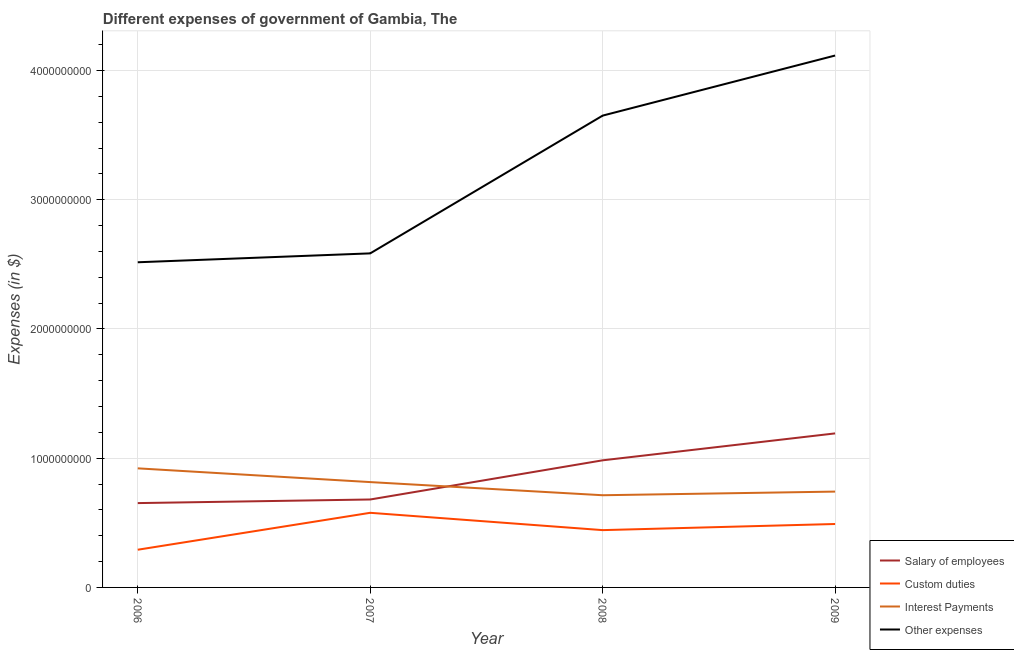What is the amount spent on other expenses in 2008?
Make the answer very short. 3.65e+09. Across all years, what is the maximum amount spent on interest payments?
Offer a very short reply. 9.21e+08. Across all years, what is the minimum amount spent on custom duties?
Your response must be concise. 2.92e+08. In which year was the amount spent on custom duties maximum?
Provide a short and direct response. 2007. In which year was the amount spent on other expenses minimum?
Give a very brief answer. 2006. What is the total amount spent on custom duties in the graph?
Offer a terse response. 1.80e+09. What is the difference between the amount spent on salary of employees in 2007 and that in 2008?
Your answer should be very brief. -3.03e+08. What is the difference between the amount spent on salary of employees in 2009 and the amount spent on other expenses in 2007?
Offer a terse response. -1.39e+09. What is the average amount spent on other expenses per year?
Provide a succinct answer. 3.22e+09. In the year 2006, what is the difference between the amount spent on salary of employees and amount spent on other expenses?
Offer a terse response. -1.86e+09. In how many years, is the amount spent on custom duties greater than 1200000000 $?
Offer a terse response. 0. What is the ratio of the amount spent on other expenses in 2007 to that in 2008?
Provide a succinct answer. 0.71. Is the difference between the amount spent on interest payments in 2006 and 2009 greater than the difference between the amount spent on other expenses in 2006 and 2009?
Offer a terse response. Yes. What is the difference between the highest and the second highest amount spent on other expenses?
Offer a terse response. 4.65e+08. What is the difference between the highest and the lowest amount spent on other expenses?
Offer a terse response. 1.60e+09. In how many years, is the amount spent on other expenses greater than the average amount spent on other expenses taken over all years?
Provide a short and direct response. 2. Is the sum of the amount spent on interest payments in 2007 and 2009 greater than the maximum amount spent on custom duties across all years?
Your response must be concise. Yes. Is it the case that in every year, the sum of the amount spent on salary of employees and amount spent on custom duties is greater than the amount spent on interest payments?
Make the answer very short. Yes. Does the amount spent on other expenses monotonically increase over the years?
Your answer should be compact. Yes. How many years are there in the graph?
Your response must be concise. 4. What is the difference between two consecutive major ticks on the Y-axis?
Ensure brevity in your answer.  1.00e+09. Are the values on the major ticks of Y-axis written in scientific E-notation?
Provide a succinct answer. No. Does the graph contain grids?
Provide a succinct answer. Yes. How many legend labels are there?
Provide a succinct answer. 4. What is the title of the graph?
Your response must be concise. Different expenses of government of Gambia, The. What is the label or title of the X-axis?
Ensure brevity in your answer.  Year. What is the label or title of the Y-axis?
Keep it short and to the point. Expenses (in $). What is the Expenses (in $) of Salary of employees in 2006?
Give a very brief answer. 6.52e+08. What is the Expenses (in $) in Custom duties in 2006?
Provide a succinct answer. 2.92e+08. What is the Expenses (in $) of Interest Payments in 2006?
Provide a succinct answer. 9.21e+08. What is the Expenses (in $) in Other expenses in 2006?
Your answer should be compact. 2.52e+09. What is the Expenses (in $) of Salary of employees in 2007?
Give a very brief answer. 6.80e+08. What is the Expenses (in $) of Custom duties in 2007?
Provide a short and direct response. 5.77e+08. What is the Expenses (in $) in Interest Payments in 2007?
Make the answer very short. 8.15e+08. What is the Expenses (in $) in Other expenses in 2007?
Provide a succinct answer. 2.58e+09. What is the Expenses (in $) of Salary of employees in 2008?
Your answer should be very brief. 9.84e+08. What is the Expenses (in $) in Custom duties in 2008?
Your answer should be compact. 4.43e+08. What is the Expenses (in $) in Interest Payments in 2008?
Give a very brief answer. 7.13e+08. What is the Expenses (in $) in Other expenses in 2008?
Your response must be concise. 3.65e+09. What is the Expenses (in $) of Salary of employees in 2009?
Give a very brief answer. 1.19e+09. What is the Expenses (in $) of Custom duties in 2009?
Make the answer very short. 4.91e+08. What is the Expenses (in $) of Interest Payments in 2009?
Provide a succinct answer. 7.42e+08. What is the Expenses (in $) in Other expenses in 2009?
Make the answer very short. 4.12e+09. Across all years, what is the maximum Expenses (in $) of Salary of employees?
Ensure brevity in your answer.  1.19e+09. Across all years, what is the maximum Expenses (in $) in Custom duties?
Provide a short and direct response. 5.77e+08. Across all years, what is the maximum Expenses (in $) of Interest Payments?
Give a very brief answer. 9.21e+08. Across all years, what is the maximum Expenses (in $) in Other expenses?
Keep it short and to the point. 4.12e+09. Across all years, what is the minimum Expenses (in $) in Salary of employees?
Your answer should be compact. 6.52e+08. Across all years, what is the minimum Expenses (in $) of Custom duties?
Ensure brevity in your answer.  2.92e+08. Across all years, what is the minimum Expenses (in $) of Interest Payments?
Your response must be concise. 7.13e+08. Across all years, what is the minimum Expenses (in $) in Other expenses?
Ensure brevity in your answer.  2.52e+09. What is the total Expenses (in $) of Salary of employees in the graph?
Your response must be concise. 3.51e+09. What is the total Expenses (in $) of Custom duties in the graph?
Provide a short and direct response. 1.80e+09. What is the total Expenses (in $) of Interest Payments in the graph?
Provide a short and direct response. 3.19e+09. What is the total Expenses (in $) of Other expenses in the graph?
Offer a terse response. 1.29e+1. What is the difference between the Expenses (in $) of Salary of employees in 2006 and that in 2007?
Keep it short and to the point. -2.79e+07. What is the difference between the Expenses (in $) of Custom duties in 2006 and that in 2007?
Your answer should be very brief. -2.86e+08. What is the difference between the Expenses (in $) of Interest Payments in 2006 and that in 2007?
Offer a very short reply. 1.06e+08. What is the difference between the Expenses (in $) of Other expenses in 2006 and that in 2007?
Keep it short and to the point. -6.88e+07. What is the difference between the Expenses (in $) in Salary of employees in 2006 and that in 2008?
Your answer should be compact. -3.31e+08. What is the difference between the Expenses (in $) of Custom duties in 2006 and that in 2008?
Provide a succinct answer. -1.52e+08. What is the difference between the Expenses (in $) in Interest Payments in 2006 and that in 2008?
Provide a short and direct response. 2.08e+08. What is the difference between the Expenses (in $) in Other expenses in 2006 and that in 2008?
Make the answer very short. -1.13e+09. What is the difference between the Expenses (in $) in Salary of employees in 2006 and that in 2009?
Ensure brevity in your answer.  -5.39e+08. What is the difference between the Expenses (in $) of Custom duties in 2006 and that in 2009?
Make the answer very short. -1.99e+08. What is the difference between the Expenses (in $) in Interest Payments in 2006 and that in 2009?
Offer a terse response. 1.80e+08. What is the difference between the Expenses (in $) in Other expenses in 2006 and that in 2009?
Offer a terse response. -1.60e+09. What is the difference between the Expenses (in $) of Salary of employees in 2007 and that in 2008?
Offer a terse response. -3.03e+08. What is the difference between the Expenses (in $) in Custom duties in 2007 and that in 2008?
Your response must be concise. 1.34e+08. What is the difference between the Expenses (in $) of Interest Payments in 2007 and that in 2008?
Your answer should be very brief. 1.02e+08. What is the difference between the Expenses (in $) in Other expenses in 2007 and that in 2008?
Your answer should be compact. -1.07e+09. What is the difference between the Expenses (in $) in Salary of employees in 2007 and that in 2009?
Ensure brevity in your answer.  -5.11e+08. What is the difference between the Expenses (in $) in Custom duties in 2007 and that in 2009?
Your answer should be compact. 8.66e+07. What is the difference between the Expenses (in $) of Interest Payments in 2007 and that in 2009?
Provide a short and direct response. 7.35e+07. What is the difference between the Expenses (in $) of Other expenses in 2007 and that in 2009?
Give a very brief answer. -1.53e+09. What is the difference between the Expenses (in $) of Salary of employees in 2008 and that in 2009?
Make the answer very short. -2.08e+08. What is the difference between the Expenses (in $) in Custom duties in 2008 and that in 2009?
Provide a succinct answer. -4.74e+07. What is the difference between the Expenses (in $) in Interest Payments in 2008 and that in 2009?
Offer a terse response. -2.82e+07. What is the difference between the Expenses (in $) of Other expenses in 2008 and that in 2009?
Ensure brevity in your answer.  -4.65e+08. What is the difference between the Expenses (in $) of Salary of employees in 2006 and the Expenses (in $) of Custom duties in 2007?
Ensure brevity in your answer.  7.51e+07. What is the difference between the Expenses (in $) of Salary of employees in 2006 and the Expenses (in $) of Interest Payments in 2007?
Provide a short and direct response. -1.62e+08. What is the difference between the Expenses (in $) of Salary of employees in 2006 and the Expenses (in $) of Other expenses in 2007?
Ensure brevity in your answer.  -1.93e+09. What is the difference between the Expenses (in $) of Custom duties in 2006 and the Expenses (in $) of Interest Payments in 2007?
Ensure brevity in your answer.  -5.23e+08. What is the difference between the Expenses (in $) in Custom duties in 2006 and the Expenses (in $) in Other expenses in 2007?
Provide a succinct answer. -2.29e+09. What is the difference between the Expenses (in $) in Interest Payments in 2006 and the Expenses (in $) in Other expenses in 2007?
Offer a very short reply. -1.66e+09. What is the difference between the Expenses (in $) in Salary of employees in 2006 and the Expenses (in $) in Custom duties in 2008?
Provide a succinct answer. 2.09e+08. What is the difference between the Expenses (in $) of Salary of employees in 2006 and the Expenses (in $) of Interest Payments in 2008?
Provide a succinct answer. -6.08e+07. What is the difference between the Expenses (in $) of Salary of employees in 2006 and the Expenses (in $) of Other expenses in 2008?
Your answer should be very brief. -3.00e+09. What is the difference between the Expenses (in $) of Custom duties in 2006 and the Expenses (in $) of Interest Payments in 2008?
Your response must be concise. -4.22e+08. What is the difference between the Expenses (in $) of Custom duties in 2006 and the Expenses (in $) of Other expenses in 2008?
Your answer should be very brief. -3.36e+09. What is the difference between the Expenses (in $) of Interest Payments in 2006 and the Expenses (in $) of Other expenses in 2008?
Ensure brevity in your answer.  -2.73e+09. What is the difference between the Expenses (in $) of Salary of employees in 2006 and the Expenses (in $) of Custom duties in 2009?
Provide a short and direct response. 1.62e+08. What is the difference between the Expenses (in $) of Salary of employees in 2006 and the Expenses (in $) of Interest Payments in 2009?
Provide a succinct answer. -8.90e+07. What is the difference between the Expenses (in $) of Salary of employees in 2006 and the Expenses (in $) of Other expenses in 2009?
Give a very brief answer. -3.46e+09. What is the difference between the Expenses (in $) in Custom duties in 2006 and the Expenses (in $) in Interest Payments in 2009?
Provide a short and direct response. -4.50e+08. What is the difference between the Expenses (in $) in Custom duties in 2006 and the Expenses (in $) in Other expenses in 2009?
Your answer should be compact. -3.82e+09. What is the difference between the Expenses (in $) in Interest Payments in 2006 and the Expenses (in $) in Other expenses in 2009?
Provide a short and direct response. -3.19e+09. What is the difference between the Expenses (in $) of Salary of employees in 2007 and the Expenses (in $) of Custom duties in 2008?
Ensure brevity in your answer.  2.37e+08. What is the difference between the Expenses (in $) in Salary of employees in 2007 and the Expenses (in $) in Interest Payments in 2008?
Give a very brief answer. -3.29e+07. What is the difference between the Expenses (in $) in Salary of employees in 2007 and the Expenses (in $) in Other expenses in 2008?
Your answer should be very brief. -2.97e+09. What is the difference between the Expenses (in $) of Custom duties in 2007 and the Expenses (in $) of Interest Payments in 2008?
Offer a terse response. -1.36e+08. What is the difference between the Expenses (in $) in Custom duties in 2007 and the Expenses (in $) in Other expenses in 2008?
Provide a succinct answer. -3.07e+09. What is the difference between the Expenses (in $) of Interest Payments in 2007 and the Expenses (in $) of Other expenses in 2008?
Offer a very short reply. -2.84e+09. What is the difference between the Expenses (in $) of Salary of employees in 2007 and the Expenses (in $) of Custom duties in 2009?
Provide a short and direct response. 1.90e+08. What is the difference between the Expenses (in $) of Salary of employees in 2007 and the Expenses (in $) of Interest Payments in 2009?
Offer a terse response. -6.11e+07. What is the difference between the Expenses (in $) in Salary of employees in 2007 and the Expenses (in $) in Other expenses in 2009?
Make the answer very short. -3.44e+09. What is the difference between the Expenses (in $) of Custom duties in 2007 and the Expenses (in $) of Interest Payments in 2009?
Your answer should be compact. -1.64e+08. What is the difference between the Expenses (in $) of Custom duties in 2007 and the Expenses (in $) of Other expenses in 2009?
Provide a short and direct response. -3.54e+09. What is the difference between the Expenses (in $) in Interest Payments in 2007 and the Expenses (in $) in Other expenses in 2009?
Your answer should be compact. -3.30e+09. What is the difference between the Expenses (in $) in Salary of employees in 2008 and the Expenses (in $) in Custom duties in 2009?
Offer a terse response. 4.93e+08. What is the difference between the Expenses (in $) in Salary of employees in 2008 and the Expenses (in $) in Interest Payments in 2009?
Provide a succinct answer. 2.42e+08. What is the difference between the Expenses (in $) of Salary of employees in 2008 and the Expenses (in $) of Other expenses in 2009?
Make the answer very short. -3.13e+09. What is the difference between the Expenses (in $) of Custom duties in 2008 and the Expenses (in $) of Interest Payments in 2009?
Make the answer very short. -2.98e+08. What is the difference between the Expenses (in $) in Custom duties in 2008 and the Expenses (in $) in Other expenses in 2009?
Provide a succinct answer. -3.67e+09. What is the difference between the Expenses (in $) in Interest Payments in 2008 and the Expenses (in $) in Other expenses in 2009?
Offer a terse response. -3.40e+09. What is the average Expenses (in $) in Salary of employees per year?
Provide a succinct answer. 8.77e+08. What is the average Expenses (in $) in Custom duties per year?
Your response must be concise. 4.51e+08. What is the average Expenses (in $) in Interest Payments per year?
Your answer should be compact. 7.98e+08. What is the average Expenses (in $) in Other expenses per year?
Your answer should be compact. 3.22e+09. In the year 2006, what is the difference between the Expenses (in $) of Salary of employees and Expenses (in $) of Custom duties?
Make the answer very short. 3.61e+08. In the year 2006, what is the difference between the Expenses (in $) in Salary of employees and Expenses (in $) in Interest Payments?
Your answer should be very brief. -2.69e+08. In the year 2006, what is the difference between the Expenses (in $) in Salary of employees and Expenses (in $) in Other expenses?
Ensure brevity in your answer.  -1.86e+09. In the year 2006, what is the difference between the Expenses (in $) in Custom duties and Expenses (in $) in Interest Payments?
Ensure brevity in your answer.  -6.30e+08. In the year 2006, what is the difference between the Expenses (in $) in Custom duties and Expenses (in $) in Other expenses?
Give a very brief answer. -2.22e+09. In the year 2006, what is the difference between the Expenses (in $) of Interest Payments and Expenses (in $) of Other expenses?
Provide a succinct answer. -1.59e+09. In the year 2007, what is the difference between the Expenses (in $) in Salary of employees and Expenses (in $) in Custom duties?
Your answer should be very brief. 1.03e+08. In the year 2007, what is the difference between the Expenses (in $) of Salary of employees and Expenses (in $) of Interest Payments?
Your response must be concise. -1.35e+08. In the year 2007, what is the difference between the Expenses (in $) of Salary of employees and Expenses (in $) of Other expenses?
Give a very brief answer. -1.90e+09. In the year 2007, what is the difference between the Expenses (in $) of Custom duties and Expenses (in $) of Interest Payments?
Your response must be concise. -2.38e+08. In the year 2007, what is the difference between the Expenses (in $) of Custom duties and Expenses (in $) of Other expenses?
Ensure brevity in your answer.  -2.01e+09. In the year 2007, what is the difference between the Expenses (in $) of Interest Payments and Expenses (in $) of Other expenses?
Ensure brevity in your answer.  -1.77e+09. In the year 2008, what is the difference between the Expenses (in $) in Salary of employees and Expenses (in $) in Custom duties?
Keep it short and to the point. 5.40e+08. In the year 2008, what is the difference between the Expenses (in $) of Salary of employees and Expenses (in $) of Interest Payments?
Keep it short and to the point. 2.70e+08. In the year 2008, what is the difference between the Expenses (in $) in Salary of employees and Expenses (in $) in Other expenses?
Offer a terse response. -2.67e+09. In the year 2008, what is the difference between the Expenses (in $) in Custom duties and Expenses (in $) in Interest Payments?
Provide a short and direct response. -2.70e+08. In the year 2008, what is the difference between the Expenses (in $) in Custom duties and Expenses (in $) in Other expenses?
Offer a very short reply. -3.21e+09. In the year 2008, what is the difference between the Expenses (in $) of Interest Payments and Expenses (in $) of Other expenses?
Offer a very short reply. -2.94e+09. In the year 2009, what is the difference between the Expenses (in $) of Salary of employees and Expenses (in $) of Custom duties?
Make the answer very short. 7.01e+08. In the year 2009, what is the difference between the Expenses (in $) of Salary of employees and Expenses (in $) of Interest Payments?
Offer a very short reply. 4.50e+08. In the year 2009, what is the difference between the Expenses (in $) of Salary of employees and Expenses (in $) of Other expenses?
Keep it short and to the point. -2.92e+09. In the year 2009, what is the difference between the Expenses (in $) of Custom duties and Expenses (in $) of Interest Payments?
Keep it short and to the point. -2.51e+08. In the year 2009, what is the difference between the Expenses (in $) of Custom duties and Expenses (in $) of Other expenses?
Provide a succinct answer. -3.62e+09. In the year 2009, what is the difference between the Expenses (in $) of Interest Payments and Expenses (in $) of Other expenses?
Provide a succinct answer. -3.37e+09. What is the ratio of the Expenses (in $) in Salary of employees in 2006 to that in 2007?
Offer a terse response. 0.96. What is the ratio of the Expenses (in $) of Custom duties in 2006 to that in 2007?
Your answer should be compact. 0.51. What is the ratio of the Expenses (in $) of Interest Payments in 2006 to that in 2007?
Offer a very short reply. 1.13. What is the ratio of the Expenses (in $) of Other expenses in 2006 to that in 2007?
Provide a short and direct response. 0.97. What is the ratio of the Expenses (in $) of Salary of employees in 2006 to that in 2008?
Provide a short and direct response. 0.66. What is the ratio of the Expenses (in $) in Custom duties in 2006 to that in 2008?
Make the answer very short. 0.66. What is the ratio of the Expenses (in $) in Interest Payments in 2006 to that in 2008?
Ensure brevity in your answer.  1.29. What is the ratio of the Expenses (in $) of Other expenses in 2006 to that in 2008?
Offer a very short reply. 0.69. What is the ratio of the Expenses (in $) in Salary of employees in 2006 to that in 2009?
Offer a terse response. 0.55. What is the ratio of the Expenses (in $) in Custom duties in 2006 to that in 2009?
Make the answer very short. 0.59. What is the ratio of the Expenses (in $) in Interest Payments in 2006 to that in 2009?
Make the answer very short. 1.24. What is the ratio of the Expenses (in $) in Other expenses in 2006 to that in 2009?
Your answer should be compact. 0.61. What is the ratio of the Expenses (in $) of Salary of employees in 2007 to that in 2008?
Give a very brief answer. 0.69. What is the ratio of the Expenses (in $) of Custom duties in 2007 to that in 2008?
Your response must be concise. 1.3. What is the ratio of the Expenses (in $) of Interest Payments in 2007 to that in 2008?
Provide a short and direct response. 1.14. What is the ratio of the Expenses (in $) of Other expenses in 2007 to that in 2008?
Make the answer very short. 0.71. What is the ratio of the Expenses (in $) in Salary of employees in 2007 to that in 2009?
Your answer should be very brief. 0.57. What is the ratio of the Expenses (in $) in Custom duties in 2007 to that in 2009?
Provide a short and direct response. 1.18. What is the ratio of the Expenses (in $) of Interest Payments in 2007 to that in 2009?
Your answer should be very brief. 1.1. What is the ratio of the Expenses (in $) of Other expenses in 2007 to that in 2009?
Offer a very short reply. 0.63. What is the ratio of the Expenses (in $) in Salary of employees in 2008 to that in 2009?
Make the answer very short. 0.83. What is the ratio of the Expenses (in $) in Custom duties in 2008 to that in 2009?
Provide a short and direct response. 0.9. What is the ratio of the Expenses (in $) of Other expenses in 2008 to that in 2009?
Your answer should be very brief. 0.89. What is the difference between the highest and the second highest Expenses (in $) of Salary of employees?
Ensure brevity in your answer.  2.08e+08. What is the difference between the highest and the second highest Expenses (in $) of Custom duties?
Your answer should be compact. 8.66e+07. What is the difference between the highest and the second highest Expenses (in $) of Interest Payments?
Offer a terse response. 1.06e+08. What is the difference between the highest and the second highest Expenses (in $) in Other expenses?
Your answer should be very brief. 4.65e+08. What is the difference between the highest and the lowest Expenses (in $) in Salary of employees?
Offer a terse response. 5.39e+08. What is the difference between the highest and the lowest Expenses (in $) in Custom duties?
Provide a short and direct response. 2.86e+08. What is the difference between the highest and the lowest Expenses (in $) of Interest Payments?
Offer a very short reply. 2.08e+08. What is the difference between the highest and the lowest Expenses (in $) of Other expenses?
Make the answer very short. 1.60e+09. 